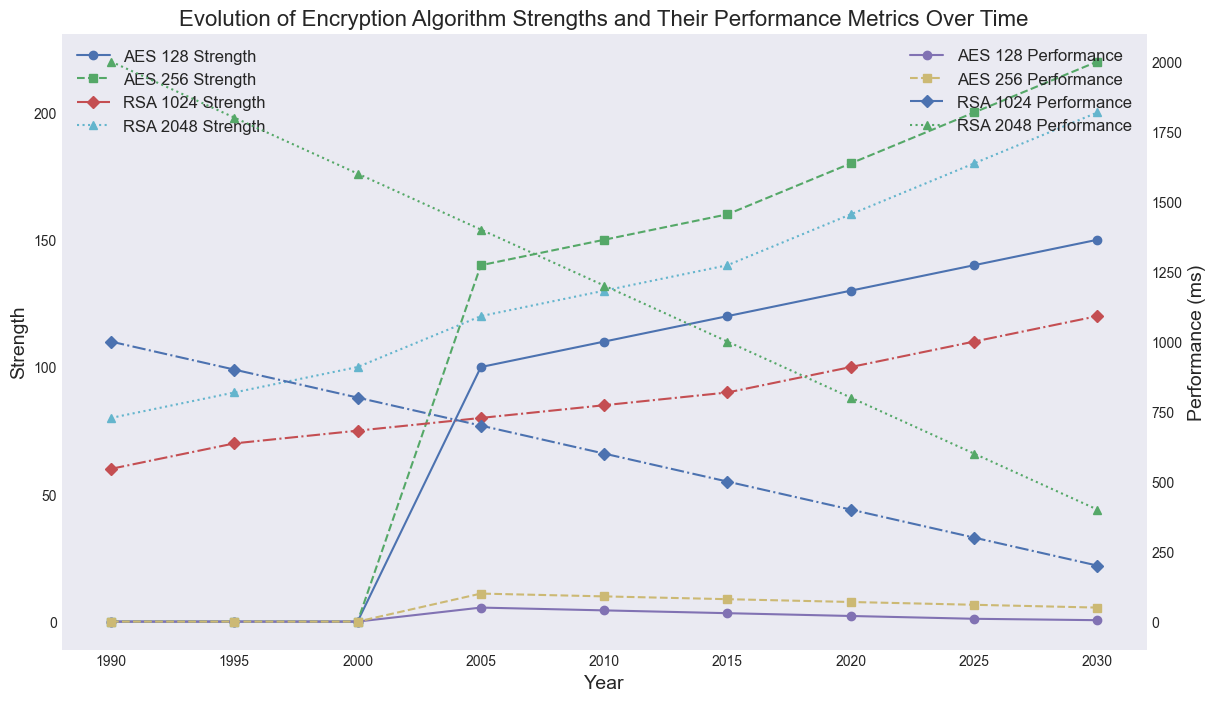Which encryption algorithm had the highest strength in 2030? Look at the data points for all algorithms in the year 2030. AES 256 has the highest strength of 220.
Answer: AES 256 How did the performance of RSA 2048 change from 1995 to 2020? Look at the performance values of RSA 2048 for the years 1995 and 2020. In 1995 it was 1800 ms, and in 2020 it was 800 ms. The performance improved (decreased) by 1000 ms.
Answer: Improved by 1000 ms Which algorithm had better performance in 2015, AES 128 or RSA 1024? Compare the performance values of AES 128 and RSA 1024 in 2015. AES 128 had a performance of 30 ms, and RSA 1024 had a performance of 500 ms. AES 128 had better performance.
Answer: AES 128 What was the strength difference between AES 128 and AES 256 in 2005? In 2005, the strengths were 100 for AES 128 and 140 for AES 256. The difference is 140 - 100 = 40.
Answer: 40 Between 1990 and 2030, which algorithm showed the greatest increase in strength? Compare the increase in strength for each algorithm from 1990 to 2030. Both AES 128 and AES 256 show no strength in 1990 but AES 256 reaches 220 in 2030. RSA 2048 increases from 80 to 200 (120), RSA 1024 from 60 to 120 (60). So, AES 256 showed the greatest increase.
Answer: AES 256 What was the median strength of AES 256 over the years presented? List out the strength values for AES 256: 0, 0, 0, 0, 140, 150, 160, 180, 200, 220. The median of these values is the average of the 5th and 6th values (140 and 150). (140 + 150) / 2 = 145.
Answer: 145 Did the performance of AES 128 improve or worsen over time? Analyze the trend of AES 128’s performance over the years. It started at 0 ms in 1990 and decreased to 5 ms by 2030, indicating an improvement.
Answer: Improved How much did the strength of RSA 1024 increase between 2000 and 2005? Look at the strength values of RSA 1024 in 2000 and 2005. In 2000 it was 75, and in 2005 it was 80. The increase is 80 - 75 = 5.
Answer: 5 In 2010, which algorithm had the shortest performance time? Compare the performance times of all algorithms in 2010: AES 128 (40 ms), AES 256 (90 ms), RSA 1024 (600 ms), and RSA 2048 (1200 ms). AES 128 had the shortest time of 40 ms.
Answer: AES 128 